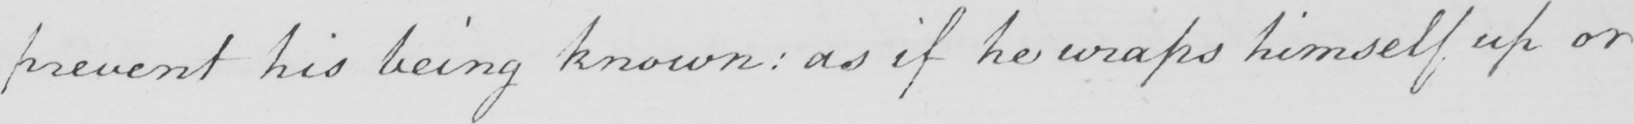What is written in this line of handwriting? prevent his being known : as if he wraps himself up or 